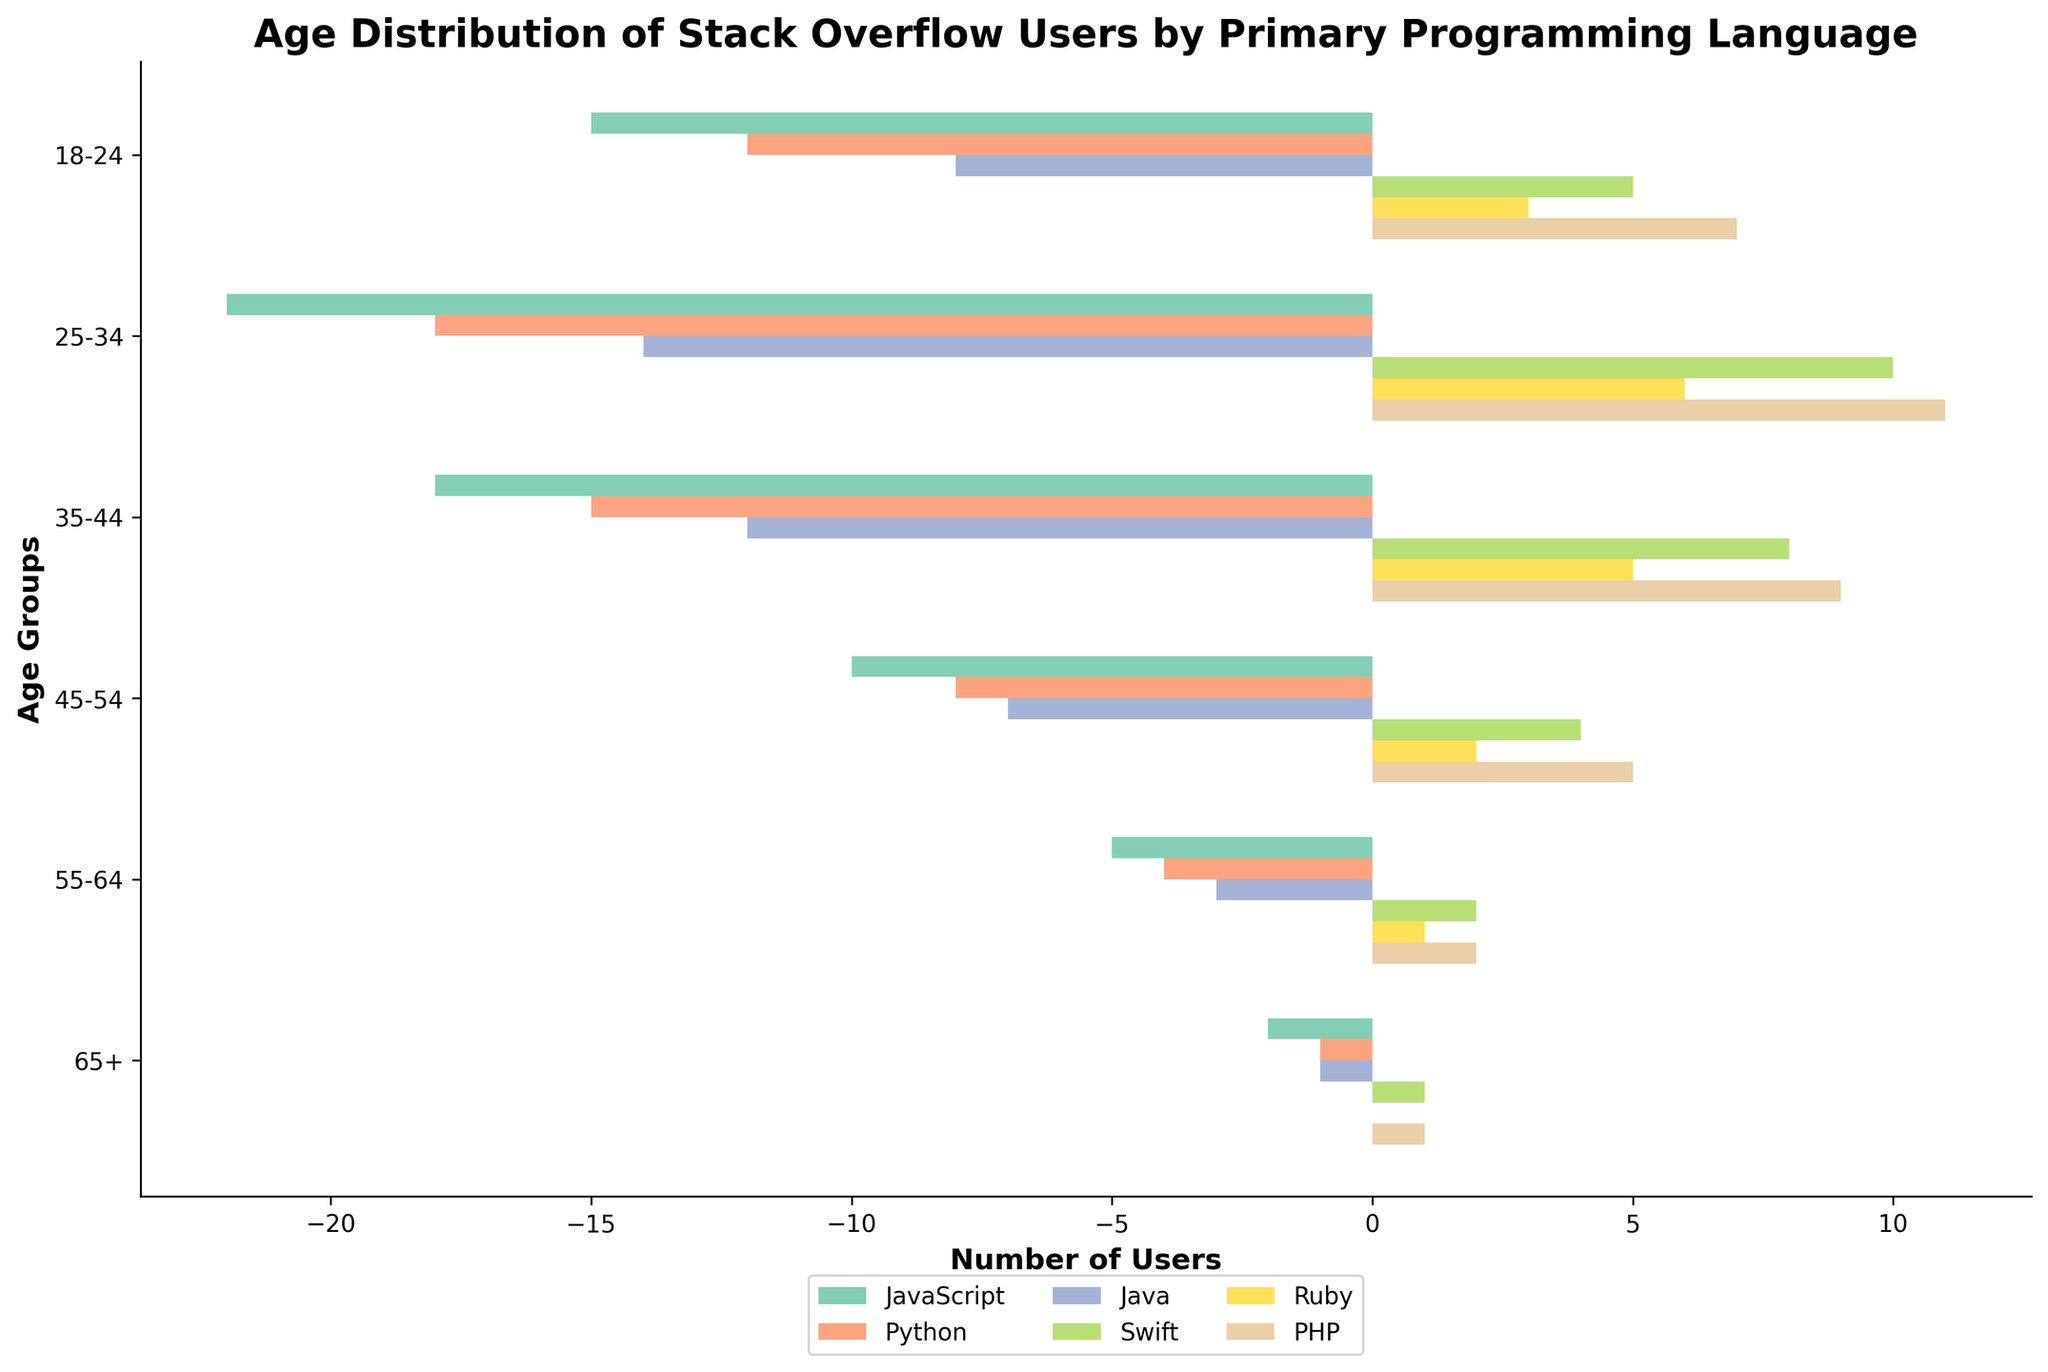What's the title of the figure? The title is typically found at the top of the figure, providing a summary of what the visual information represents. In this case, the title is "Age Distribution of Stack Overflow Users by Primary Programming Language"
Answer: Age Distribution of Stack Overflow Users by Primary Programming Language What are the age groups listed on the y-axis? The age groups are displayed on the y-axis, from top to bottom. They include: 18-24, 25-34, 35-44, 45-54, 55-64, and 65+
Answer: 18-24, 25-34, 35-44, 45-54, 55-64, 65+ Which programming language has the highest number of users in the 25-34 age group? Look at the bars corresponding to the 25-34 age group and compare their lengths. The longest bar represents the highest number of users. In this case, JavaScript has the highest number of users in this age group.
Answer: JavaScript What's the total number of users aged 55-64? Sum up the user counts for all programming languages in the 55-64 age group: JavaScript (5) + Python (4) + Java (3) + Swift (2) + Ruby (1) + PHP (2) = 17
Answer: 17 Which age group has the least number of Python users? Identify the shortest bar among the Python user bars. The shortest bar is in the 65+ age group, indicating only 1 Python user in this group.
Answer: 65+ How many more JavaScript users than Ruby users are there in the 35-44 age group? Subtract the number of Ruby users from the number of JavaScript users in the 35-44 age group: JavaScript (18) - Ruby (5) = 13
Answer: 13 What's the average number of PHP users across all age groups? Calculate the mean of PHP users by summing the PHP users in all age groups and dividing by the number of age groups: (7+11+9+5+2+1)/6 = 35/6 ≈ 5.83
Answer: 5.83 Which age group has a higher number of Swift users, 35-44 or 45-54? Compare the bar lengths for Swift users in the 35-44 and 45-54 age groups. The 35-44 age group has 8 users, and the 45-54 age group has 4 users. Thus, 35-44 has more users.
Answer: 35-44 What’s the sum of the users in the 18-24 and 65+ age groups for all languages? Add the number of users across all languages for both 18-24 and 65+ age groups: (15+12+8+5+3+7) + (2+1+1+1+0+1) = 50 + 6 = 56
Answer: 56 What's the overall trend in user numbers as age increases for JavaScript? Observe the trend of the JavaScript bars from the youngest to the oldest age group. The numbers decrease as age increases, indicating fewer older JavaScript users.
Answer: Decreasing trend 